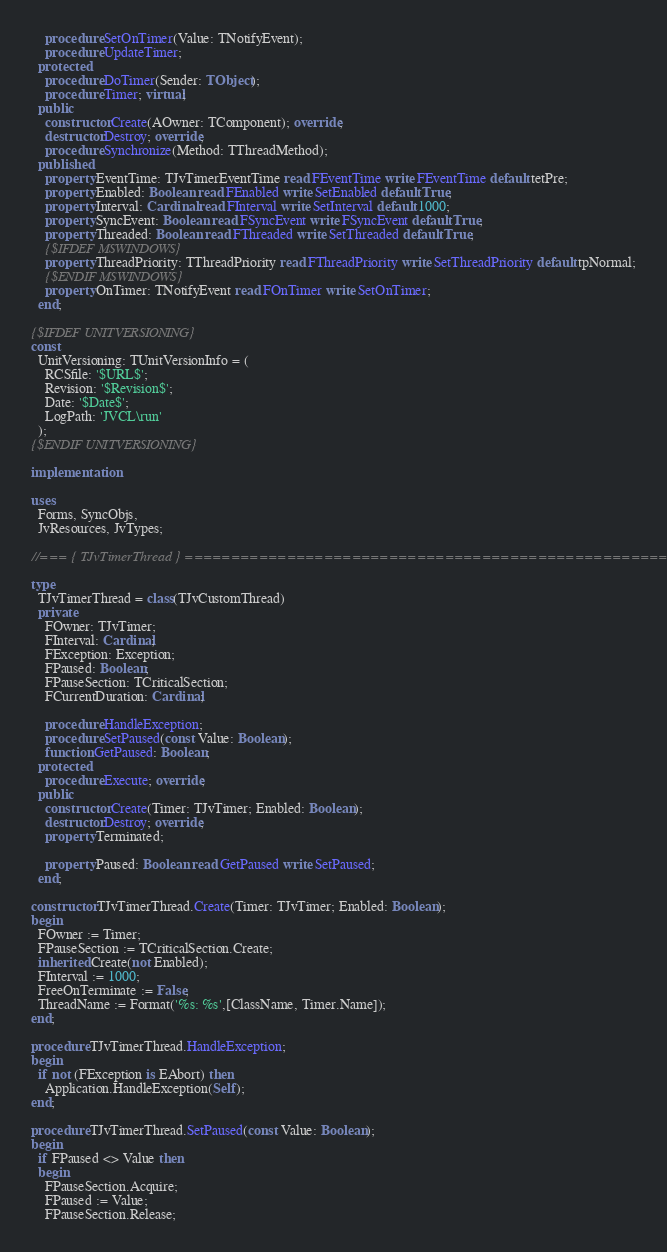Convert code to text. <code><loc_0><loc_0><loc_500><loc_500><_Pascal_>    procedure SetOnTimer(Value: TNotifyEvent);
    procedure UpdateTimer;
  protected
    procedure DoTimer(Sender: TObject);
    procedure Timer; virtual;
  public
    constructor Create(AOwner: TComponent); override;
    destructor Destroy; override;
    procedure Synchronize(Method: TThreadMethod);
  published
    property EventTime: TJvTimerEventTime read FEventTime write FEventTime default tetPre;
    property Enabled: Boolean read FEnabled write SetEnabled default True;
    property Interval: Cardinal read FInterval write SetInterval default 1000;
    property SyncEvent: Boolean read FSyncEvent write FSyncEvent default True;
    property Threaded: Boolean read FThreaded write SetThreaded default True;
    {$IFDEF MSWINDOWS}
    property ThreadPriority: TThreadPriority read FThreadPriority write SetThreadPriority default tpNormal;
    {$ENDIF MSWINDOWS}
    property OnTimer: TNotifyEvent read FOnTimer write SetOnTimer;
  end;

{$IFDEF UNITVERSIONING}
const
  UnitVersioning: TUnitVersionInfo = (
    RCSfile: '$URL$';
    Revision: '$Revision$';
    Date: '$Date$';
    LogPath: 'JVCL\run'
  );
{$ENDIF UNITVERSIONING}

implementation

uses
  Forms, SyncObjs,
  JvResources, JvTypes;

//=== { TJvTimerThread } =====================================================

type
  TJvTimerThread = class(TJvCustomThread)
  private
    FOwner: TJvTimer;
    FInterval: Cardinal;
    FException: Exception;
    FPaused: Boolean;
    FPauseSection: TCriticalSection;
    FCurrentDuration: Cardinal;

    procedure HandleException;
    procedure SetPaused(const Value: Boolean);
    function GetPaused: Boolean;
  protected
    procedure Execute; override;
  public
    constructor Create(Timer: TJvTimer; Enabled: Boolean);
    destructor Destroy; override;
    property Terminated;

    property Paused: Boolean read GetPaused write SetPaused;
  end;

constructor TJvTimerThread.Create(Timer: TJvTimer; Enabled: Boolean);
begin
  FOwner := Timer;
  FPauseSection := TCriticalSection.Create;
  inherited Create(not Enabled);
  FInterval := 1000;
  FreeOnTerminate := False;
  ThreadName := Format('%s: %s',[ClassName, Timer.Name]);
end;

procedure TJvTimerThread.HandleException;
begin
  if not (FException is EAbort) then
    Application.HandleException(Self);
end;

procedure TJvTimerThread.SetPaused(const Value: Boolean);
begin
  if FPaused <> Value then
  begin
    FPauseSection.Acquire;
    FPaused := Value;
    FPauseSection.Release;
</code> 